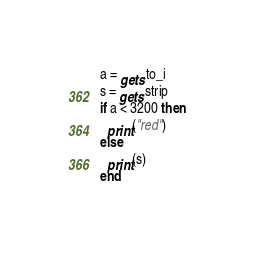<code> <loc_0><loc_0><loc_500><loc_500><_Ruby_>a = gets.to_i
s = gets.strip
if a < 3200 then
  print("red")
else
  print(s)
end</code> 